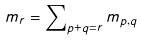<formula> <loc_0><loc_0><loc_500><loc_500>m _ { r } = \sum \nolimits _ { p + q = r } m _ { p , q }</formula> 